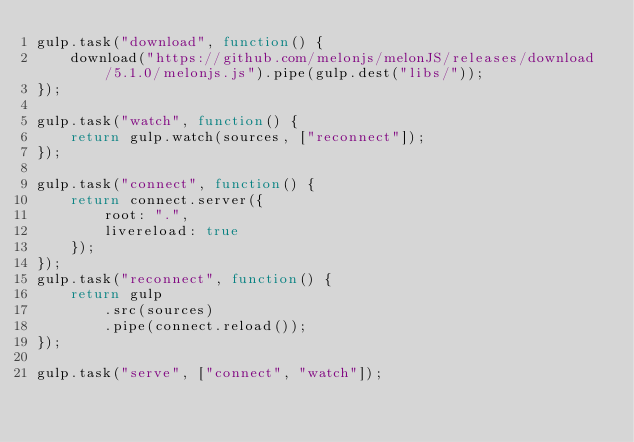Convert code to text. <code><loc_0><loc_0><loc_500><loc_500><_JavaScript_>gulp.task("download", function() {
    download("https://github.com/melonjs/melonJS/releases/download/5.1.0/melonjs.js").pipe(gulp.dest("libs/"));
});

gulp.task("watch", function() {
    return gulp.watch(sources, ["reconnect"]);
});

gulp.task("connect", function() {
    return connect.server({
        root: ".",
        livereload: true
    });
});
gulp.task("reconnect", function() {
    return gulp
        .src(sources)
        .pipe(connect.reload());
});

gulp.task("serve", ["connect", "watch"]);
</code> 